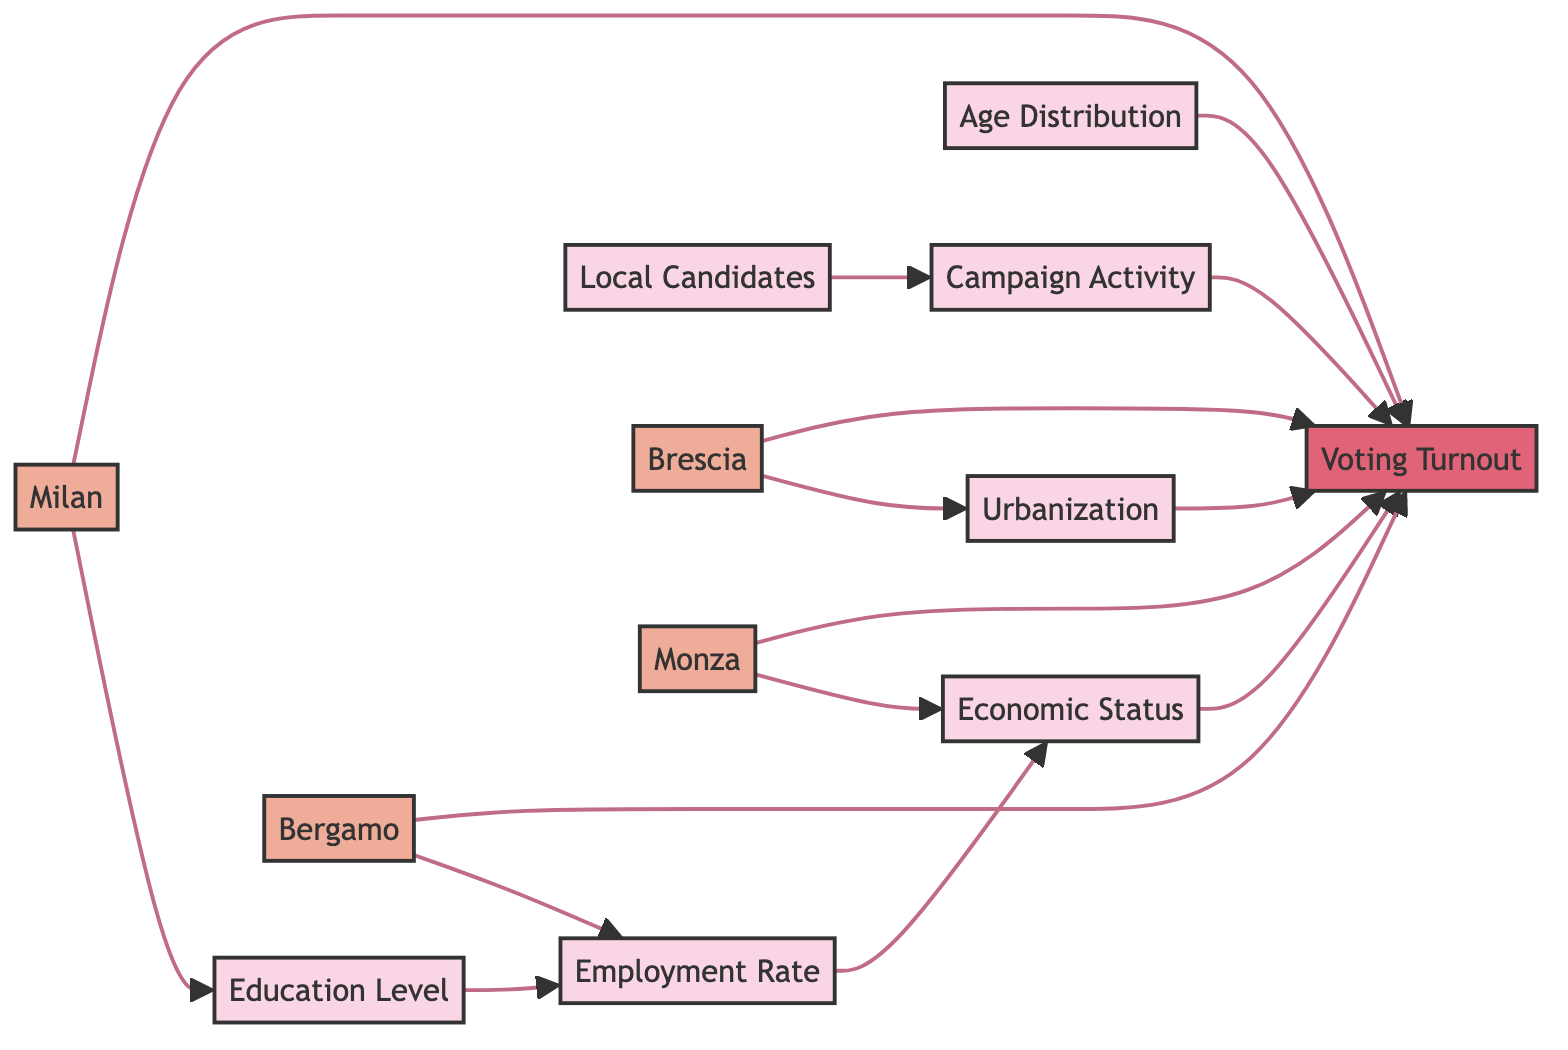What nodes are directly connected to Voting Turnout? The nodes that are directly connected to Voting Turnout, as shown in the diagram, are Economic Status, Ages Distribution, Urbanization, Campaign Activity, Milan, Bergamo, Brescia, and Monza.
Answer: Economic Status, Ages Distribution, Urbanization, Campaign Activity, Milan, Bergamo, Brescia, Monza How many nodes are there in the diagram? Counting all the unique points in the diagram, we have 12 nodes: Economic Status, Employment Rate, Education Level, Ages Distribution, Urbanization, Local Candidates, Campaign Activity, Voting Turnout, Milan, Bergamo, Brescia, and Monza.
Answer: 12 Which socio-economic factor has the most edges connected to it? By examining the connections, Education Level, Employment Rate, and Campaign Activity each have multiple connections, but the one leading to Voting Turnout has the most edges: Employment Rate influences Economic Status and connects to Voting Turnout, thus it has direct and indirect connections.
Answer: Education Level What is the relationship between Education Level and Voting Turnout? Education Level connects to Employment Rate, which in turn connects to Economic Status, and finally, Economic Status connects to Voting Turnout. This shows a chain where Education influences Employment, which influences Economic Status, ultimately affecting Voting Turnout.
Answer: Indirect through Employment Rate and Economic Status Which location influences Voting Turnout through Education Level? The only location connected to the Education Level node is Milan. Therefore, Milan influences Voting Turnout indirectly through Education Level.
Answer: Milan What socio-economic factor directly influences Employment Rate? Education Level directly influences Employment Rate, as shown in the diagram by the edge connecting the two.
Answer: Education Level Which locations are directly connected to Urbanization? The only locations that have direct connections to Urbanization are Brescia, which means it is the only city associated with the Urbanization node regarding its connection.
Answer: Brescia How many edges influence Voting Turnout? By counting all the edges that lead into the Voting Turnout node, we find there are 8 edges influencing it from various nodes such as Economic Status, Ages Distribution, Urbanization, Campaign Activity, and multiple locations.
Answer: 8 